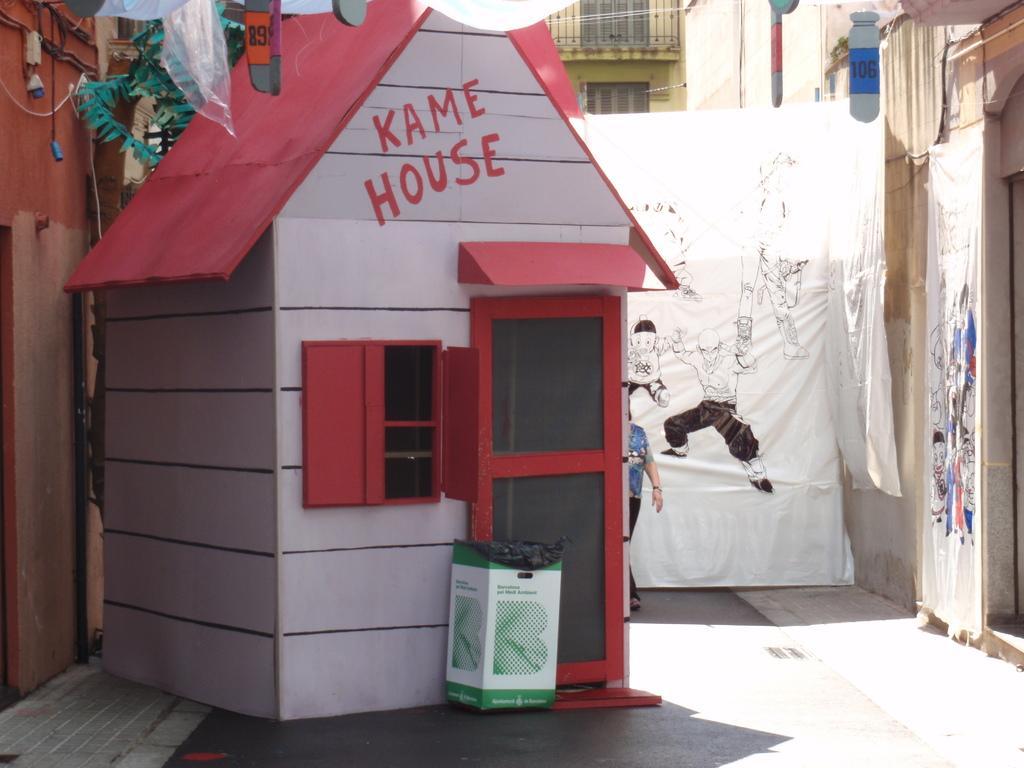In one or two sentences, can you explain what this image depicts? This looks like a small house with a door and a window. I think this is a cardboard box. Here is a person standing. This looks like a banner with the pictures on it. These are the buildings with the windows. I can see the paper crafts, which are hanging. 